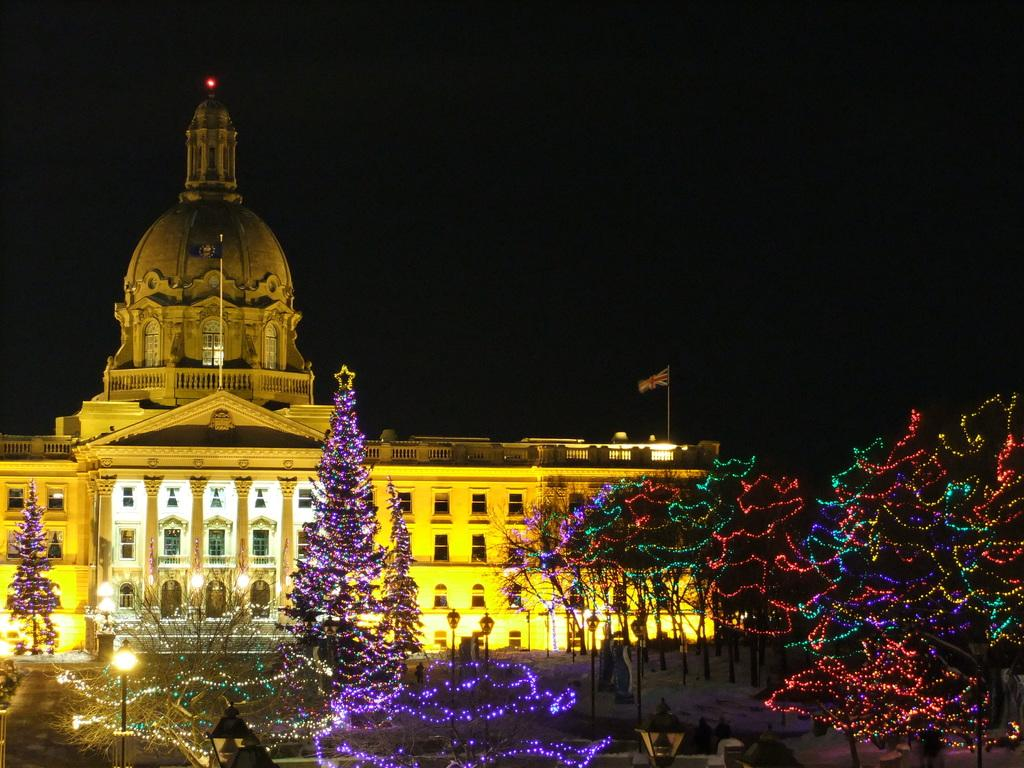What type of decoration can be seen on the trees in the image? There are trees with colorful lights in the image. What type of structure is visible in the image? There is a building in the image. What is attached to the pole in the image? There is a flag with a pole in the image. How would you describe the lighting conditions in the image? The background of the image is dark. What type of oatmeal is being served in the field in the image? There is no field or oatmeal present in the image. How many carts are visible in the image? There are no carts visible in the image. 